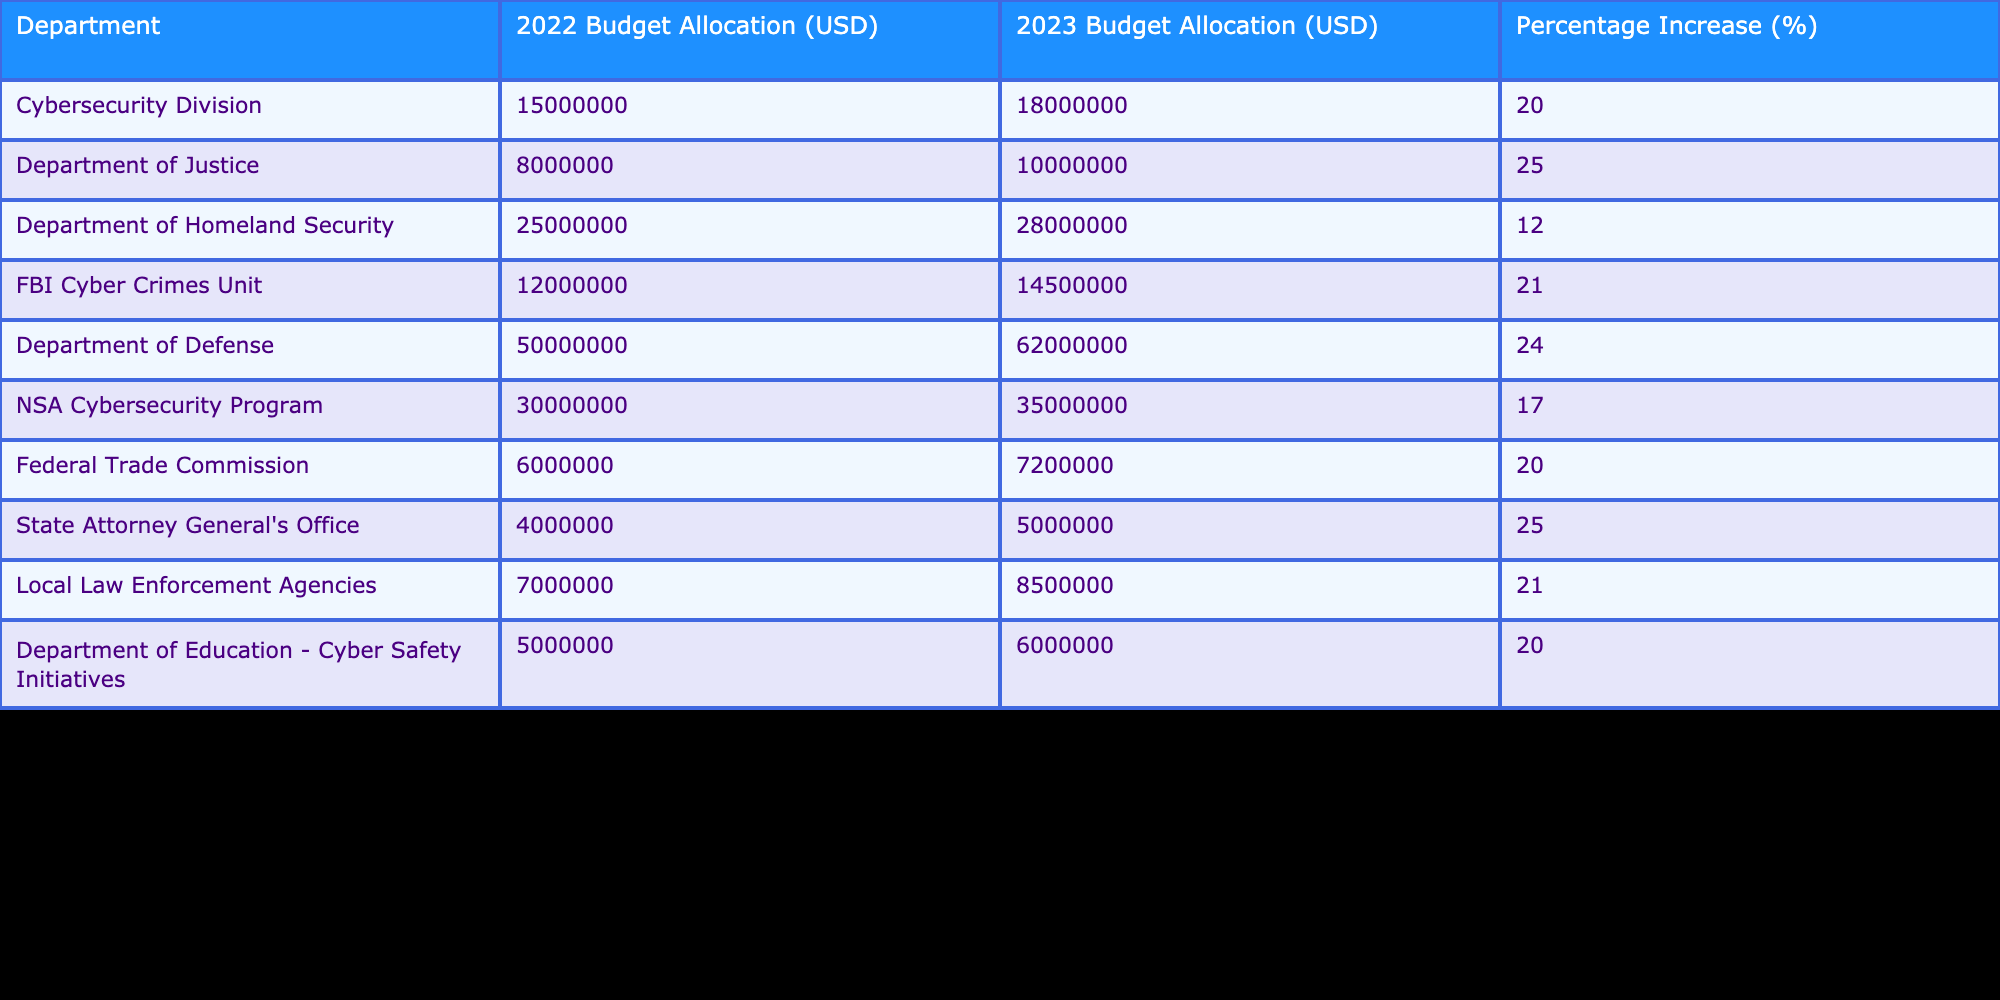What was the budget allocation for the Cybersecurity Division in 2022? According to the table, the budget allocation for the Cybersecurity Division in 2022 is listed under the column "2022 Budget Allocation (USD)" and shows a value of 15,000,000 USD.
Answer: 15,000,000 USD Which department saw the highest budget allocation in 2023? By comparing the values in the "2023 Budget Allocation (USD)" column, the Department of Defense has the highest allocation at 62,000,000 USD, surpassing all other departments.
Answer: Department of Defense What is the percentage increase of the FBI Cyber Crimes Unit budget from 2022 to 2023? The percentage increase is found in the column labeled "Percentage Increase (%)" specifically for the FBI Cyber Crimes Unit, which shows a value of 21%.
Answer: 21% How much total budget was allocated to cybersecurity initiatives across all departments in 2023? To find the total budget allocated in 2023, add all values in the "2023 Budget Allocation (USD)" column: 18,000,000 + 10,000,000 + 28,000,000 + 14,500,000 + 62,000,000 + 35,000,000 + 7,200,000 + 5,000,000 + 8,500,000 + 6,000,000 =  280,200,000 USD.
Answer: 280,200,000 USD Did the Federal Trade Commission experience a budget increase of more than 20% from 2022 to 2023? By reviewing the "Percentage Increase (%)" for the Federal Trade Commission in the table, which shows a value of 20%, we see that it did not exceed 20%. Therefore, the statement is false.
Answer: No Which department had the smallest budget allocation in 2023 and what was it? Looking at the "2023 Budget Allocation (USD)" column, the State Attorney General's Office has the smallest budget allocation of 5,000,000 USD, making it the department with the least amount allocated in that year.
Answer: State Attorney General's Office, 5,000,000 USD What is the average percentage increase across all departments listed? To calculate the average percentage increase, first sum all the values from the "Percentage Increase (%)" column: (20 + 25 + 12 + 21 + 24 + 17 + 20 + 25 + 21 + 20) =  205. Then, divide by the number of departments, which is 10: 205 / 10 = 20.5.
Answer: 20.5% How many departments had a budget allocation increase of at least 20% in 2023? By analyzing the "Percentage Increase (%)" column, we see that six departments had increases of 20% or more: Cybersecurity Division, Department of Justice, FBI Cyber Crimes Unit, Department of Defense, Federal Trade Commission, and Local Law Enforcement Agencies.
Answer: 6 